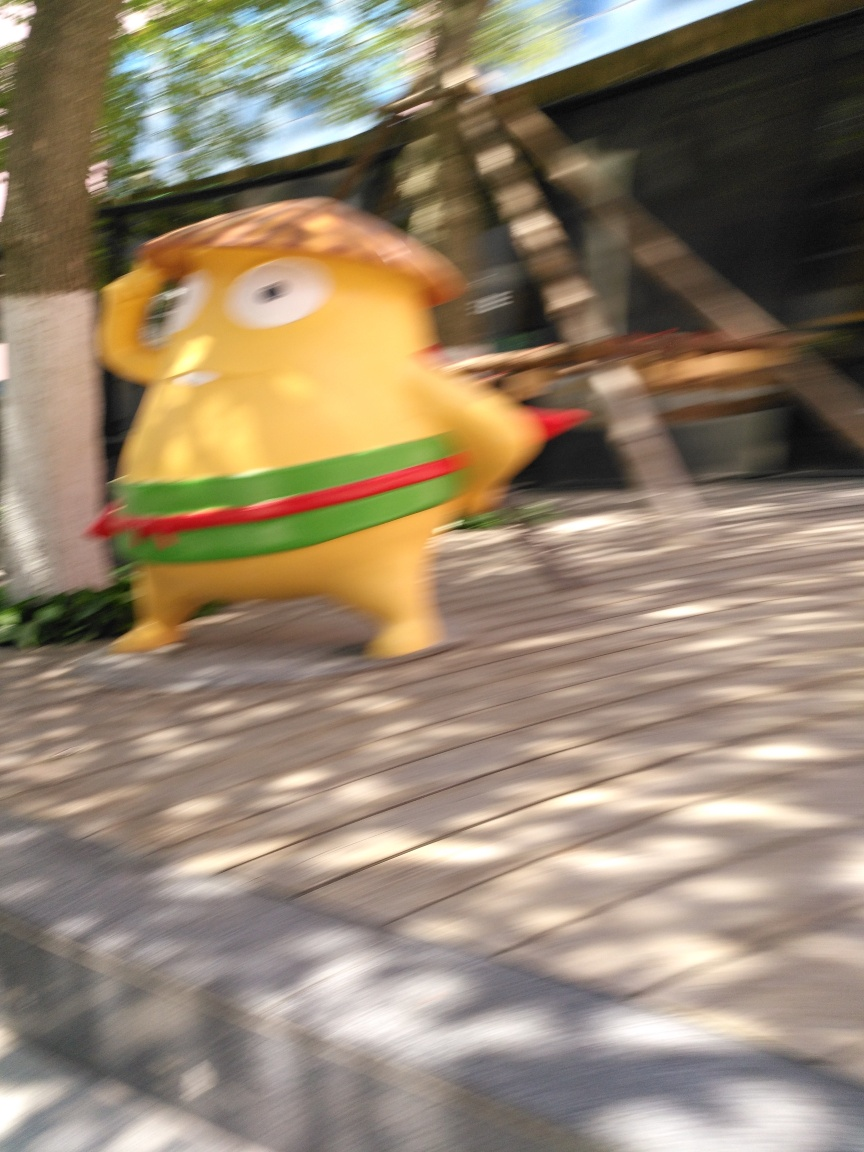What is the subject in this blurred image? The blurred subject in the image appears to be a whimsically shaped object or character with a bright yellow color and some red and green details, resembling an animated or stylized figure. 